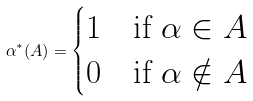<formula> <loc_0><loc_0><loc_500><loc_500>\alpha ^ { * } ( A ) = \begin{cases} 1 & \text {if $\alpha\in A$} \\ 0 & \text {if $\alpha\notin A$} \end{cases}</formula> 